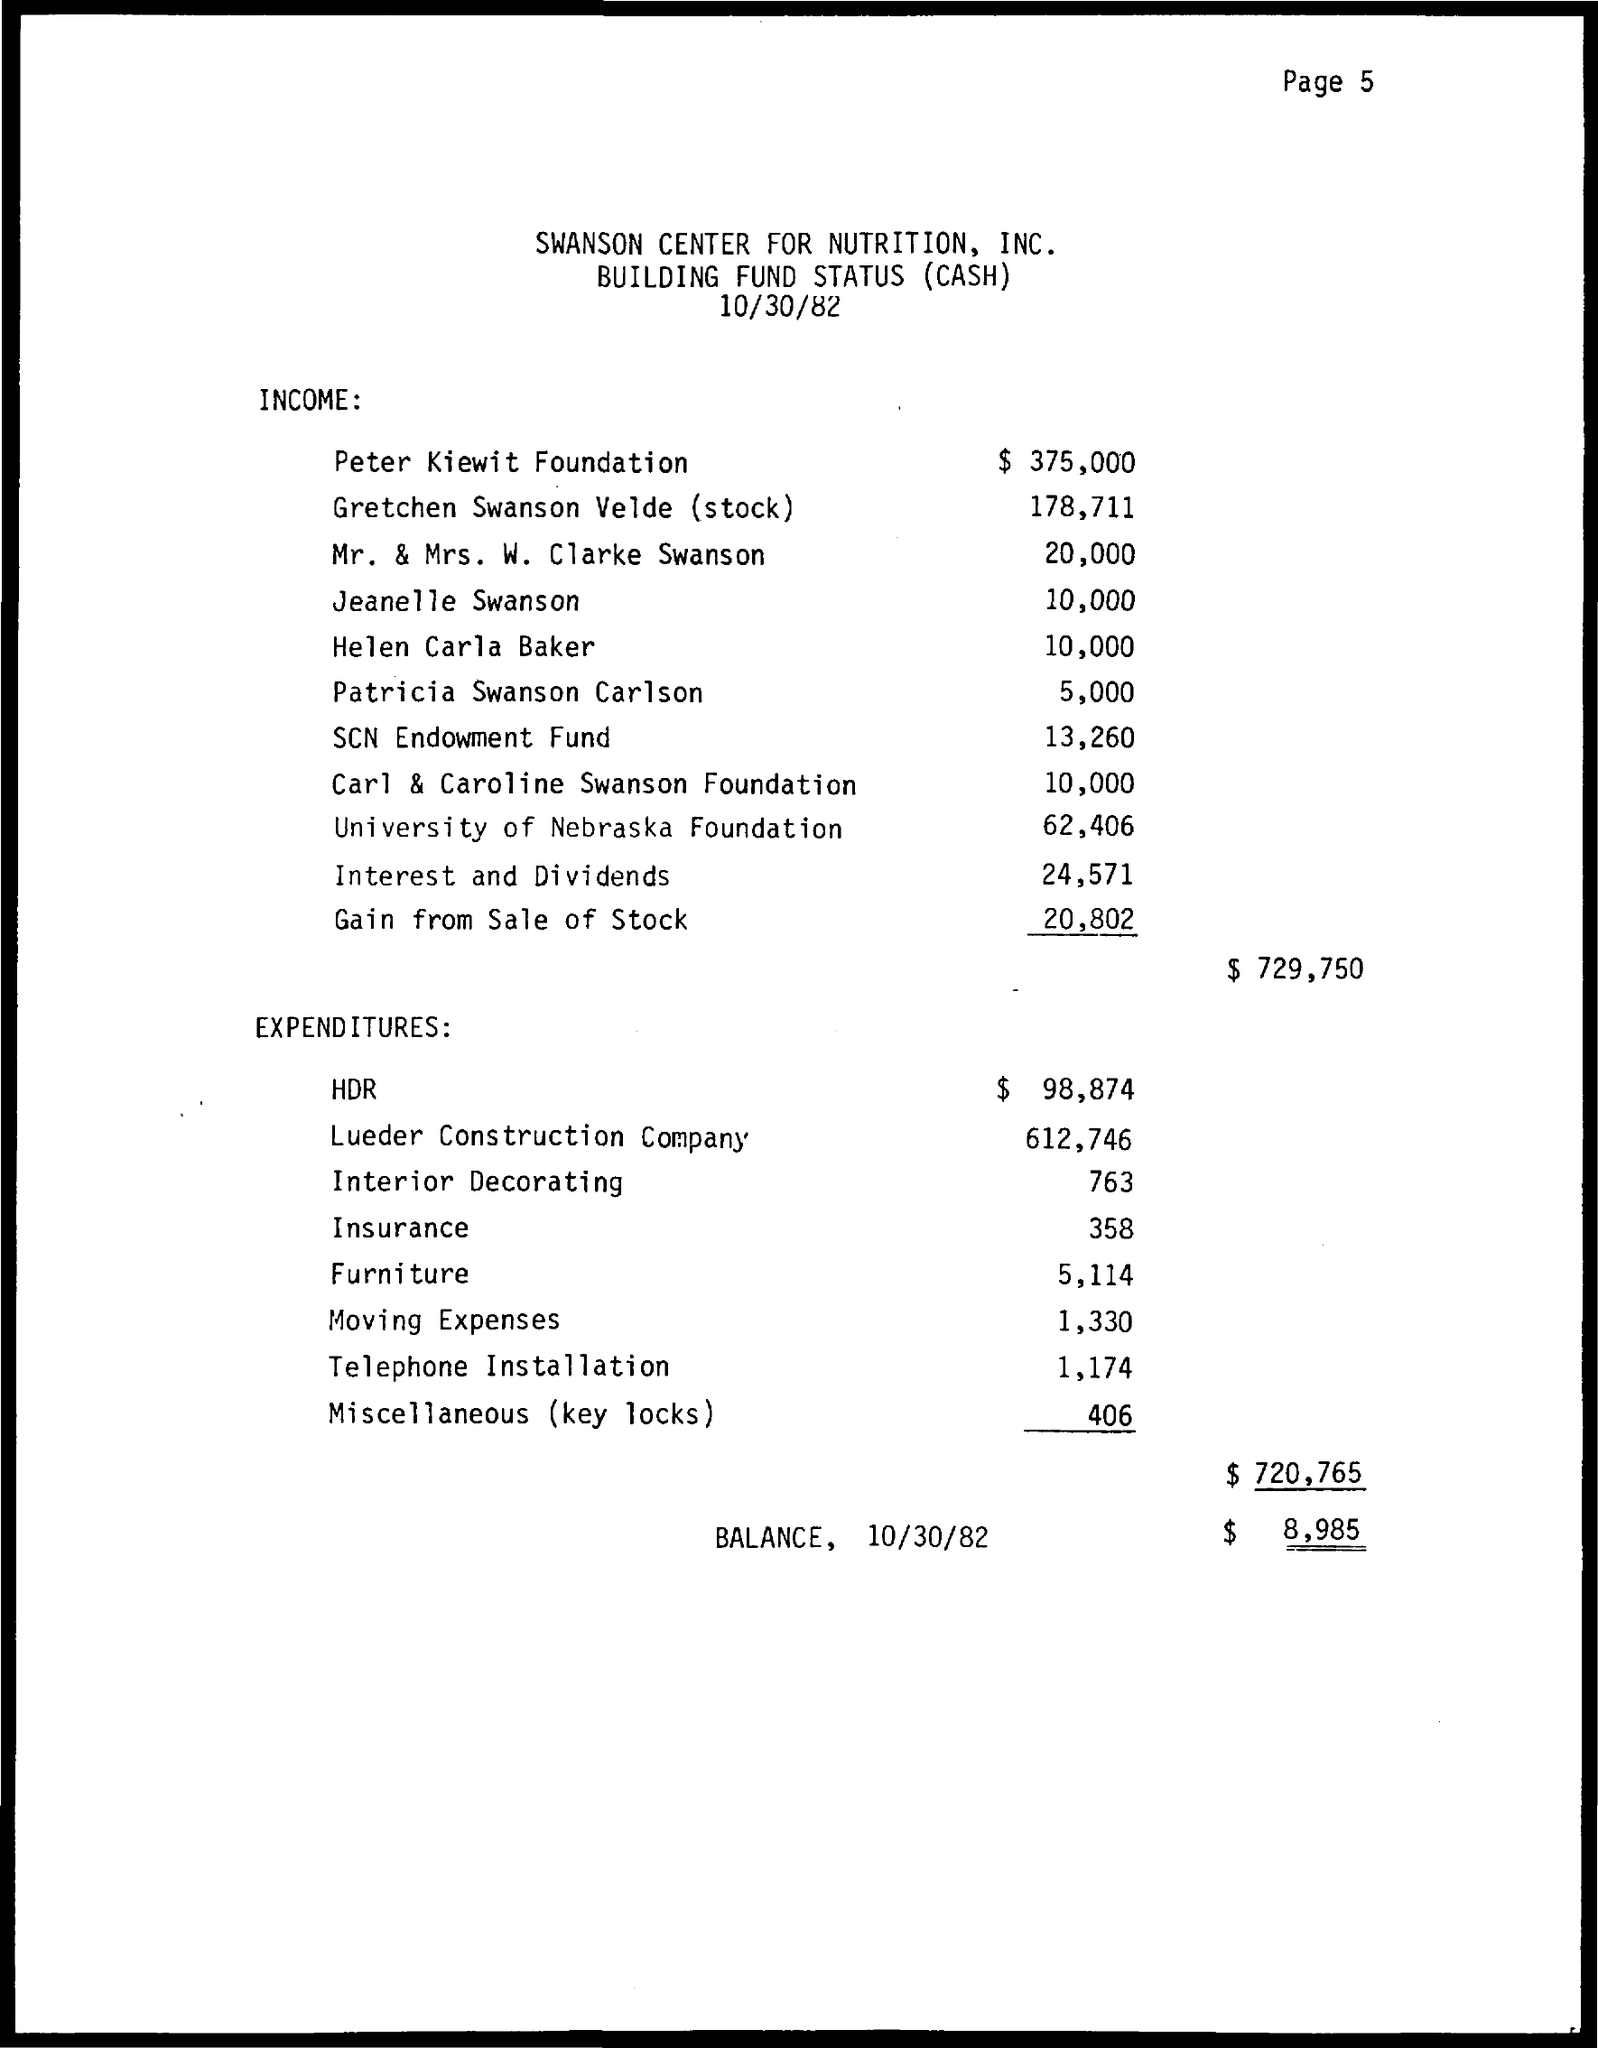What is the name of the organization given in the title?
Ensure brevity in your answer.  Swanson center for nutrition, inc. What is the date mentioned in the document?
Give a very brief answer. 10/30/82. 